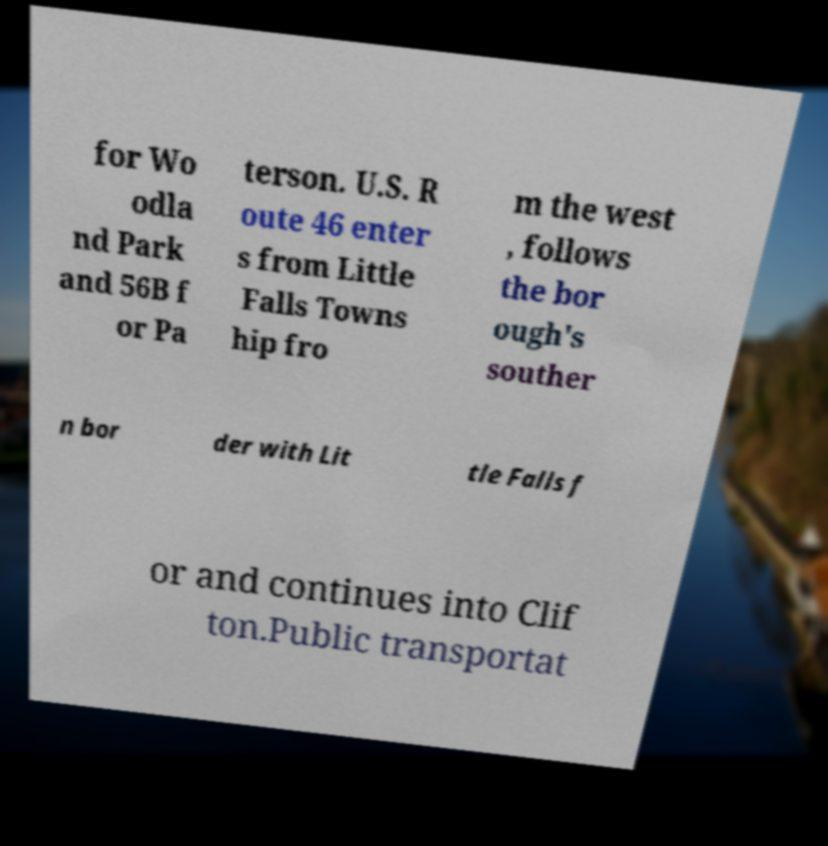What messages or text are displayed in this image? I need them in a readable, typed format. for Wo odla nd Park and 56B f or Pa terson. U.S. R oute 46 enter s from Little Falls Towns hip fro m the west , follows the bor ough's souther n bor der with Lit tle Falls f or and continues into Clif ton.Public transportat 